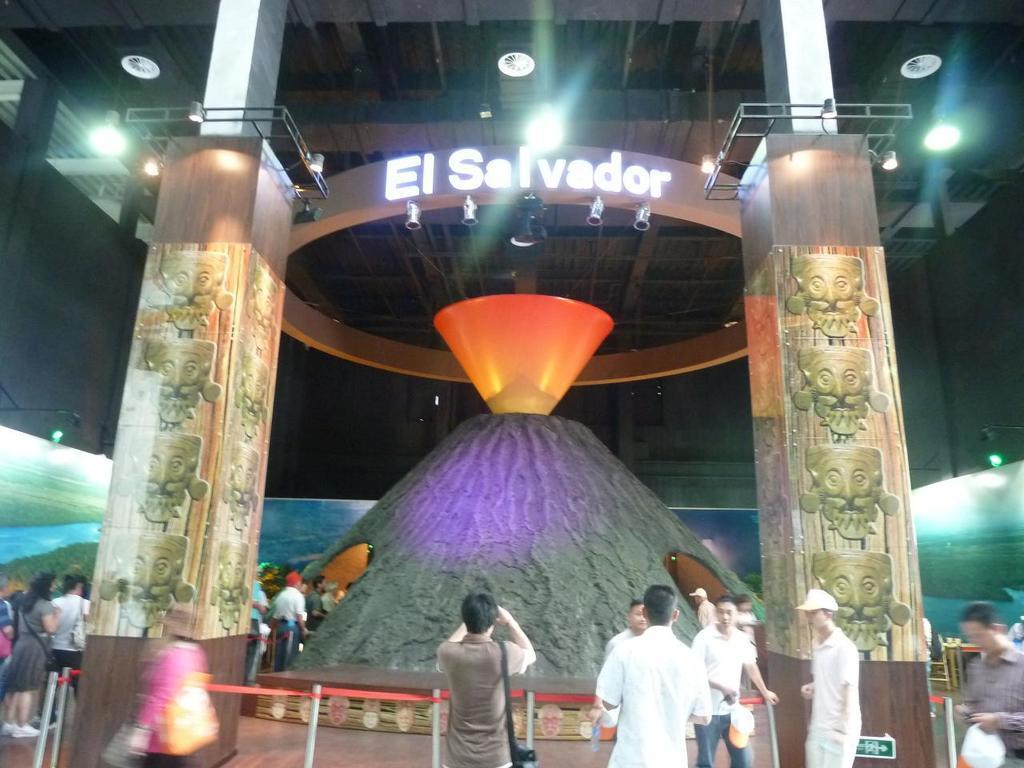How would you summarize this image in a sentence or two? In the image there are people standing inside the museum with a hill in the middle and lights over the ceiling. 